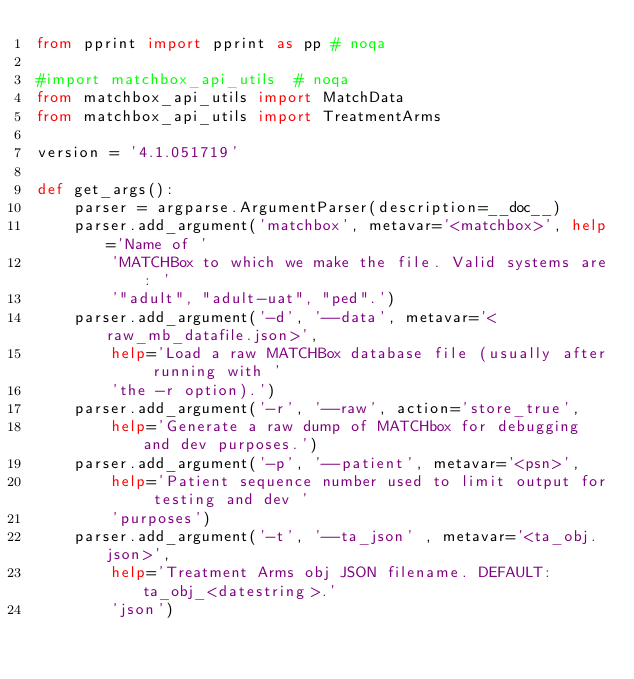Convert code to text. <code><loc_0><loc_0><loc_500><loc_500><_Python_>from pprint import pprint as pp # noqa

#import matchbox_api_utils  # noqa
from matchbox_api_utils import MatchData
from matchbox_api_utils import TreatmentArms

version = '4.1.051719'

def get_args():
    parser = argparse.ArgumentParser(description=__doc__)
    parser.add_argument('matchbox', metavar='<matchbox>', help='Name of '
        'MATCHBox to which we make the file. Valid systems are: '
        '"adult", "adult-uat", "ped".')
    parser.add_argument('-d', '--data', metavar='<raw_mb_datafile.json>',
        help='Load a raw MATCHBox database file (usually after running with '
        'the -r option).')
    parser.add_argument('-r', '--raw', action='store_true',
        help='Generate a raw dump of MATCHbox for debugging and dev purposes.')
    parser.add_argument('-p', '--patient', metavar='<psn>', 
        help='Patient sequence number used to limit output for testing and dev '
        'purposes')
    parser.add_argument('-t', '--ta_json' , metavar='<ta_obj.json>',
        help='Treatment Arms obj JSON filename. DEFAULT: ta_obj_<datestring>.'
        'json')</code> 